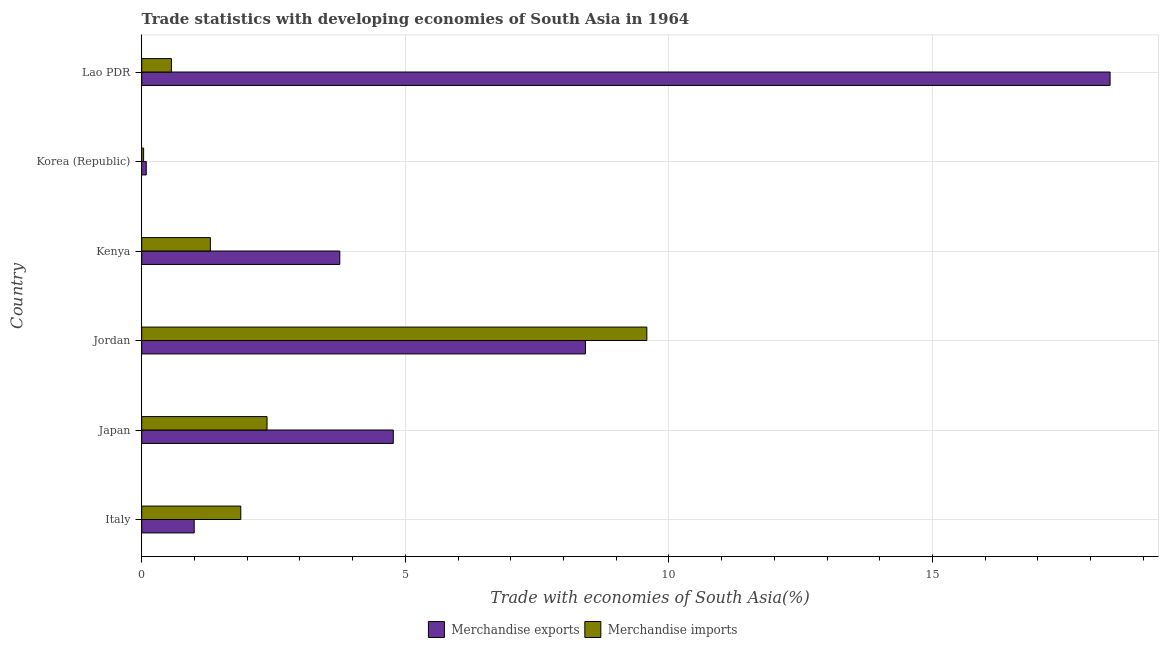How many different coloured bars are there?
Offer a very short reply. 2. How many groups of bars are there?
Give a very brief answer. 6. Are the number of bars per tick equal to the number of legend labels?
Give a very brief answer. Yes. Are the number of bars on each tick of the Y-axis equal?
Offer a very short reply. Yes. How many bars are there on the 4th tick from the top?
Make the answer very short. 2. What is the label of the 4th group of bars from the top?
Keep it short and to the point. Jordan. What is the merchandise exports in Japan?
Provide a succinct answer. 4.77. Across all countries, what is the maximum merchandise exports?
Offer a very short reply. 18.37. Across all countries, what is the minimum merchandise exports?
Your answer should be very brief. 0.09. In which country was the merchandise imports maximum?
Provide a short and direct response. Jordan. In which country was the merchandise imports minimum?
Give a very brief answer. Korea (Republic). What is the total merchandise imports in the graph?
Offer a terse response. 15.74. What is the difference between the merchandise imports in Korea (Republic) and that in Lao PDR?
Provide a short and direct response. -0.53. What is the difference between the merchandise exports in Japan and the merchandise imports in Korea (Republic)?
Your answer should be very brief. 4.74. What is the average merchandise imports per country?
Ensure brevity in your answer.  2.62. What is the difference between the merchandise exports and merchandise imports in Japan?
Provide a short and direct response. 2.4. What is the ratio of the merchandise imports in Jordan to that in Lao PDR?
Offer a very short reply. 17.01. What is the difference between the highest and the second highest merchandise imports?
Offer a very short reply. 7.2. What is the difference between the highest and the lowest merchandise exports?
Ensure brevity in your answer.  18.28. In how many countries, is the merchandise imports greater than the average merchandise imports taken over all countries?
Ensure brevity in your answer.  1. Is the sum of the merchandise exports in Jordan and Korea (Republic) greater than the maximum merchandise imports across all countries?
Make the answer very short. No. What does the 1st bar from the top in Lao PDR represents?
Keep it short and to the point. Merchandise imports. What does the 2nd bar from the bottom in Korea (Republic) represents?
Provide a succinct answer. Merchandise imports. What is the difference between two consecutive major ticks on the X-axis?
Keep it short and to the point. 5. Does the graph contain any zero values?
Ensure brevity in your answer.  No. What is the title of the graph?
Your response must be concise. Trade statistics with developing economies of South Asia in 1964. What is the label or title of the X-axis?
Provide a succinct answer. Trade with economies of South Asia(%). What is the Trade with economies of South Asia(%) of Merchandise exports in Italy?
Your response must be concise. 1. What is the Trade with economies of South Asia(%) in Merchandise imports in Italy?
Your answer should be very brief. 1.88. What is the Trade with economies of South Asia(%) of Merchandise exports in Japan?
Give a very brief answer. 4.77. What is the Trade with economies of South Asia(%) in Merchandise imports in Japan?
Give a very brief answer. 2.38. What is the Trade with economies of South Asia(%) in Merchandise exports in Jordan?
Make the answer very short. 8.42. What is the Trade with economies of South Asia(%) of Merchandise imports in Jordan?
Make the answer very short. 9.58. What is the Trade with economies of South Asia(%) in Merchandise exports in Kenya?
Your answer should be very brief. 3.76. What is the Trade with economies of South Asia(%) of Merchandise imports in Kenya?
Provide a succinct answer. 1.3. What is the Trade with economies of South Asia(%) of Merchandise exports in Korea (Republic)?
Make the answer very short. 0.09. What is the Trade with economies of South Asia(%) in Merchandise imports in Korea (Republic)?
Your answer should be very brief. 0.04. What is the Trade with economies of South Asia(%) in Merchandise exports in Lao PDR?
Give a very brief answer. 18.37. What is the Trade with economies of South Asia(%) of Merchandise imports in Lao PDR?
Provide a short and direct response. 0.56. Across all countries, what is the maximum Trade with economies of South Asia(%) in Merchandise exports?
Ensure brevity in your answer.  18.37. Across all countries, what is the maximum Trade with economies of South Asia(%) in Merchandise imports?
Your answer should be compact. 9.58. Across all countries, what is the minimum Trade with economies of South Asia(%) of Merchandise exports?
Ensure brevity in your answer.  0.09. Across all countries, what is the minimum Trade with economies of South Asia(%) of Merchandise imports?
Keep it short and to the point. 0.04. What is the total Trade with economies of South Asia(%) of Merchandise exports in the graph?
Ensure brevity in your answer.  36.39. What is the total Trade with economies of South Asia(%) in Merchandise imports in the graph?
Keep it short and to the point. 15.74. What is the difference between the Trade with economies of South Asia(%) of Merchandise exports in Italy and that in Japan?
Offer a terse response. -3.78. What is the difference between the Trade with economies of South Asia(%) of Merchandise imports in Italy and that in Japan?
Your answer should be compact. -0.5. What is the difference between the Trade with economies of South Asia(%) of Merchandise exports in Italy and that in Jordan?
Give a very brief answer. -7.42. What is the difference between the Trade with economies of South Asia(%) of Merchandise imports in Italy and that in Jordan?
Provide a short and direct response. -7.7. What is the difference between the Trade with economies of South Asia(%) of Merchandise exports in Italy and that in Kenya?
Provide a succinct answer. -2.76. What is the difference between the Trade with economies of South Asia(%) of Merchandise imports in Italy and that in Kenya?
Provide a short and direct response. 0.58. What is the difference between the Trade with economies of South Asia(%) in Merchandise exports in Italy and that in Korea (Republic)?
Your answer should be very brief. 0.91. What is the difference between the Trade with economies of South Asia(%) in Merchandise imports in Italy and that in Korea (Republic)?
Provide a short and direct response. 1.84. What is the difference between the Trade with economies of South Asia(%) in Merchandise exports in Italy and that in Lao PDR?
Provide a succinct answer. -17.37. What is the difference between the Trade with economies of South Asia(%) in Merchandise imports in Italy and that in Lao PDR?
Keep it short and to the point. 1.32. What is the difference between the Trade with economies of South Asia(%) of Merchandise exports in Japan and that in Jordan?
Keep it short and to the point. -3.64. What is the difference between the Trade with economies of South Asia(%) in Merchandise imports in Japan and that in Jordan?
Offer a very short reply. -7.2. What is the difference between the Trade with economies of South Asia(%) of Merchandise exports in Japan and that in Kenya?
Make the answer very short. 1.01. What is the difference between the Trade with economies of South Asia(%) of Merchandise imports in Japan and that in Kenya?
Offer a very short reply. 1.07. What is the difference between the Trade with economies of South Asia(%) in Merchandise exports in Japan and that in Korea (Republic)?
Your response must be concise. 4.69. What is the difference between the Trade with economies of South Asia(%) of Merchandise imports in Japan and that in Korea (Republic)?
Ensure brevity in your answer.  2.34. What is the difference between the Trade with economies of South Asia(%) in Merchandise exports in Japan and that in Lao PDR?
Provide a succinct answer. -13.6. What is the difference between the Trade with economies of South Asia(%) in Merchandise imports in Japan and that in Lao PDR?
Give a very brief answer. 1.81. What is the difference between the Trade with economies of South Asia(%) of Merchandise exports in Jordan and that in Kenya?
Provide a succinct answer. 4.66. What is the difference between the Trade with economies of South Asia(%) of Merchandise imports in Jordan and that in Kenya?
Ensure brevity in your answer.  8.28. What is the difference between the Trade with economies of South Asia(%) of Merchandise exports in Jordan and that in Korea (Republic)?
Offer a very short reply. 8.33. What is the difference between the Trade with economies of South Asia(%) of Merchandise imports in Jordan and that in Korea (Republic)?
Keep it short and to the point. 9.54. What is the difference between the Trade with economies of South Asia(%) of Merchandise exports in Jordan and that in Lao PDR?
Keep it short and to the point. -9.95. What is the difference between the Trade with economies of South Asia(%) of Merchandise imports in Jordan and that in Lao PDR?
Keep it short and to the point. 9.02. What is the difference between the Trade with economies of South Asia(%) of Merchandise exports in Kenya and that in Korea (Republic)?
Make the answer very short. 3.67. What is the difference between the Trade with economies of South Asia(%) of Merchandise imports in Kenya and that in Korea (Republic)?
Offer a very short reply. 1.27. What is the difference between the Trade with economies of South Asia(%) of Merchandise exports in Kenya and that in Lao PDR?
Your response must be concise. -14.61. What is the difference between the Trade with economies of South Asia(%) in Merchandise imports in Kenya and that in Lao PDR?
Offer a terse response. 0.74. What is the difference between the Trade with economies of South Asia(%) of Merchandise exports in Korea (Republic) and that in Lao PDR?
Provide a short and direct response. -18.28. What is the difference between the Trade with economies of South Asia(%) in Merchandise imports in Korea (Republic) and that in Lao PDR?
Your answer should be very brief. -0.53. What is the difference between the Trade with economies of South Asia(%) in Merchandise exports in Italy and the Trade with economies of South Asia(%) in Merchandise imports in Japan?
Offer a terse response. -1.38. What is the difference between the Trade with economies of South Asia(%) of Merchandise exports in Italy and the Trade with economies of South Asia(%) of Merchandise imports in Jordan?
Offer a terse response. -8.59. What is the difference between the Trade with economies of South Asia(%) of Merchandise exports in Italy and the Trade with economies of South Asia(%) of Merchandise imports in Kenya?
Provide a succinct answer. -0.31. What is the difference between the Trade with economies of South Asia(%) in Merchandise exports in Italy and the Trade with economies of South Asia(%) in Merchandise imports in Korea (Republic)?
Make the answer very short. 0.96. What is the difference between the Trade with economies of South Asia(%) of Merchandise exports in Italy and the Trade with economies of South Asia(%) of Merchandise imports in Lao PDR?
Give a very brief answer. 0.43. What is the difference between the Trade with economies of South Asia(%) in Merchandise exports in Japan and the Trade with economies of South Asia(%) in Merchandise imports in Jordan?
Give a very brief answer. -4.81. What is the difference between the Trade with economies of South Asia(%) of Merchandise exports in Japan and the Trade with economies of South Asia(%) of Merchandise imports in Kenya?
Provide a short and direct response. 3.47. What is the difference between the Trade with economies of South Asia(%) of Merchandise exports in Japan and the Trade with economies of South Asia(%) of Merchandise imports in Korea (Republic)?
Give a very brief answer. 4.74. What is the difference between the Trade with economies of South Asia(%) of Merchandise exports in Japan and the Trade with economies of South Asia(%) of Merchandise imports in Lao PDR?
Provide a succinct answer. 4.21. What is the difference between the Trade with economies of South Asia(%) of Merchandise exports in Jordan and the Trade with economies of South Asia(%) of Merchandise imports in Kenya?
Ensure brevity in your answer.  7.11. What is the difference between the Trade with economies of South Asia(%) of Merchandise exports in Jordan and the Trade with economies of South Asia(%) of Merchandise imports in Korea (Republic)?
Provide a short and direct response. 8.38. What is the difference between the Trade with economies of South Asia(%) in Merchandise exports in Jordan and the Trade with economies of South Asia(%) in Merchandise imports in Lao PDR?
Offer a terse response. 7.85. What is the difference between the Trade with economies of South Asia(%) of Merchandise exports in Kenya and the Trade with economies of South Asia(%) of Merchandise imports in Korea (Republic)?
Your answer should be compact. 3.72. What is the difference between the Trade with economies of South Asia(%) of Merchandise exports in Kenya and the Trade with economies of South Asia(%) of Merchandise imports in Lao PDR?
Make the answer very short. 3.19. What is the difference between the Trade with economies of South Asia(%) in Merchandise exports in Korea (Republic) and the Trade with economies of South Asia(%) in Merchandise imports in Lao PDR?
Provide a succinct answer. -0.48. What is the average Trade with economies of South Asia(%) in Merchandise exports per country?
Offer a terse response. 6.07. What is the average Trade with economies of South Asia(%) in Merchandise imports per country?
Provide a succinct answer. 2.62. What is the difference between the Trade with economies of South Asia(%) in Merchandise exports and Trade with economies of South Asia(%) in Merchandise imports in Italy?
Make the answer very short. -0.88. What is the difference between the Trade with economies of South Asia(%) in Merchandise exports and Trade with economies of South Asia(%) in Merchandise imports in Japan?
Keep it short and to the point. 2.39. What is the difference between the Trade with economies of South Asia(%) in Merchandise exports and Trade with economies of South Asia(%) in Merchandise imports in Jordan?
Your answer should be very brief. -1.16. What is the difference between the Trade with economies of South Asia(%) of Merchandise exports and Trade with economies of South Asia(%) of Merchandise imports in Kenya?
Provide a succinct answer. 2.45. What is the difference between the Trade with economies of South Asia(%) of Merchandise exports and Trade with economies of South Asia(%) of Merchandise imports in Korea (Republic)?
Your answer should be compact. 0.05. What is the difference between the Trade with economies of South Asia(%) in Merchandise exports and Trade with economies of South Asia(%) in Merchandise imports in Lao PDR?
Make the answer very short. 17.8. What is the ratio of the Trade with economies of South Asia(%) in Merchandise exports in Italy to that in Japan?
Offer a very short reply. 0.21. What is the ratio of the Trade with economies of South Asia(%) of Merchandise imports in Italy to that in Japan?
Keep it short and to the point. 0.79. What is the ratio of the Trade with economies of South Asia(%) of Merchandise exports in Italy to that in Jordan?
Make the answer very short. 0.12. What is the ratio of the Trade with economies of South Asia(%) in Merchandise imports in Italy to that in Jordan?
Offer a very short reply. 0.2. What is the ratio of the Trade with economies of South Asia(%) of Merchandise exports in Italy to that in Kenya?
Keep it short and to the point. 0.26. What is the ratio of the Trade with economies of South Asia(%) in Merchandise imports in Italy to that in Kenya?
Provide a succinct answer. 1.44. What is the ratio of the Trade with economies of South Asia(%) in Merchandise exports in Italy to that in Korea (Republic)?
Your answer should be compact. 11.59. What is the ratio of the Trade with economies of South Asia(%) of Merchandise imports in Italy to that in Korea (Republic)?
Your answer should be very brief. 52.18. What is the ratio of the Trade with economies of South Asia(%) of Merchandise exports in Italy to that in Lao PDR?
Offer a terse response. 0.05. What is the ratio of the Trade with economies of South Asia(%) in Merchandise imports in Italy to that in Lao PDR?
Offer a very short reply. 3.34. What is the ratio of the Trade with economies of South Asia(%) in Merchandise exports in Japan to that in Jordan?
Provide a succinct answer. 0.57. What is the ratio of the Trade with economies of South Asia(%) of Merchandise imports in Japan to that in Jordan?
Provide a succinct answer. 0.25. What is the ratio of the Trade with economies of South Asia(%) in Merchandise exports in Japan to that in Kenya?
Offer a terse response. 1.27. What is the ratio of the Trade with economies of South Asia(%) in Merchandise imports in Japan to that in Kenya?
Ensure brevity in your answer.  1.83. What is the ratio of the Trade with economies of South Asia(%) of Merchandise exports in Japan to that in Korea (Republic)?
Keep it short and to the point. 55.54. What is the ratio of the Trade with economies of South Asia(%) in Merchandise imports in Japan to that in Korea (Republic)?
Keep it short and to the point. 66.02. What is the ratio of the Trade with economies of South Asia(%) of Merchandise exports in Japan to that in Lao PDR?
Provide a short and direct response. 0.26. What is the ratio of the Trade with economies of South Asia(%) in Merchandise imports in Japan to that in Lao PDR?
Your response must be concise. 4.22. What is the ratio of the Trade with economies of South Asia(%) in Merchandise exports in Jordan to that in Kenya?
Make the answer very short. 2.24. What is the ratio of the Trade with economies of South Asia(%) in Merchandise imports in Jordan to that in Kenya?
Ensure brevity in your answer.  7.36. What is the ratio of the Trade with economies of South Asia(%) in Merchandise exports in Jordan to that in Korea (Republic)?
Give a very brief answer. 97.96. What is the ratio of the Trade with economies of South Asia(%) in Merchandise imports in Jordan to that in Korea (Republic)?
Ensure brevity in your answer.  266.08. What is the ratio of the Trade with economies of South Asia(%) of Merchandise exports in Jordan to that in Lao PDR?
Make the answer very short. 0.46. What is the ratio of the Trade with economies of South Asia(%) in Merchandise imports in Jordan to that in Lao PDR?
Your answer should be compact. 17.01. What is the ratio of the Trade with economies of South Asia(%) in Merchandise exports in Kenya to that in Korea (Republic)?
Ensure brevity in your answer.  43.73. What is the ratio of the Trade with economies of South Asia(%) in Merchandise imports in Kenya to that in Korea (Republic)?
Give a very brief answer. 36.16. What is the ratio of the Trade with economies of South Asia(%) of Merchandise exports in Kenya to that in Lao PDR?
Your answer should be very brief. 0.2. What is the ratio of the Trade with economies of South Asia(%) in Merchandise imports in Kenya to that in Lao PDR?
Your answer should be very brief. 2.31. What is the ratio of the Trade with economies of South Asia(%) in Merchandise exports in Korea (Republic) to that in Lao PDR?
Provide a succinct answer. 0. What is the ratio of the Trade with economies of South Asia(%) of Merchandise imports in Korea (Republic) to that in Lao PDR?
Offer a terse response. 0.06. What is the difference between the highest and the second highest Trade with economies of South Asia(%) in Merchandise exports?
Your response must be concise. 9.95. What is the difference between the highest and the second highest Trade with economies of South Asia(%) of Merchandise imports?
Offer a very short reply. 7.2. What is the difference between the highest and the lowest Trade with economies of South Asia(%) of Merchandise exports?
Ensure brevity in your answer.  18.28. What is the difference between the highest and the lowest Trade with economies of South Asia(%) in Merchandise imports?
Your answer should be compact. 9.54. 